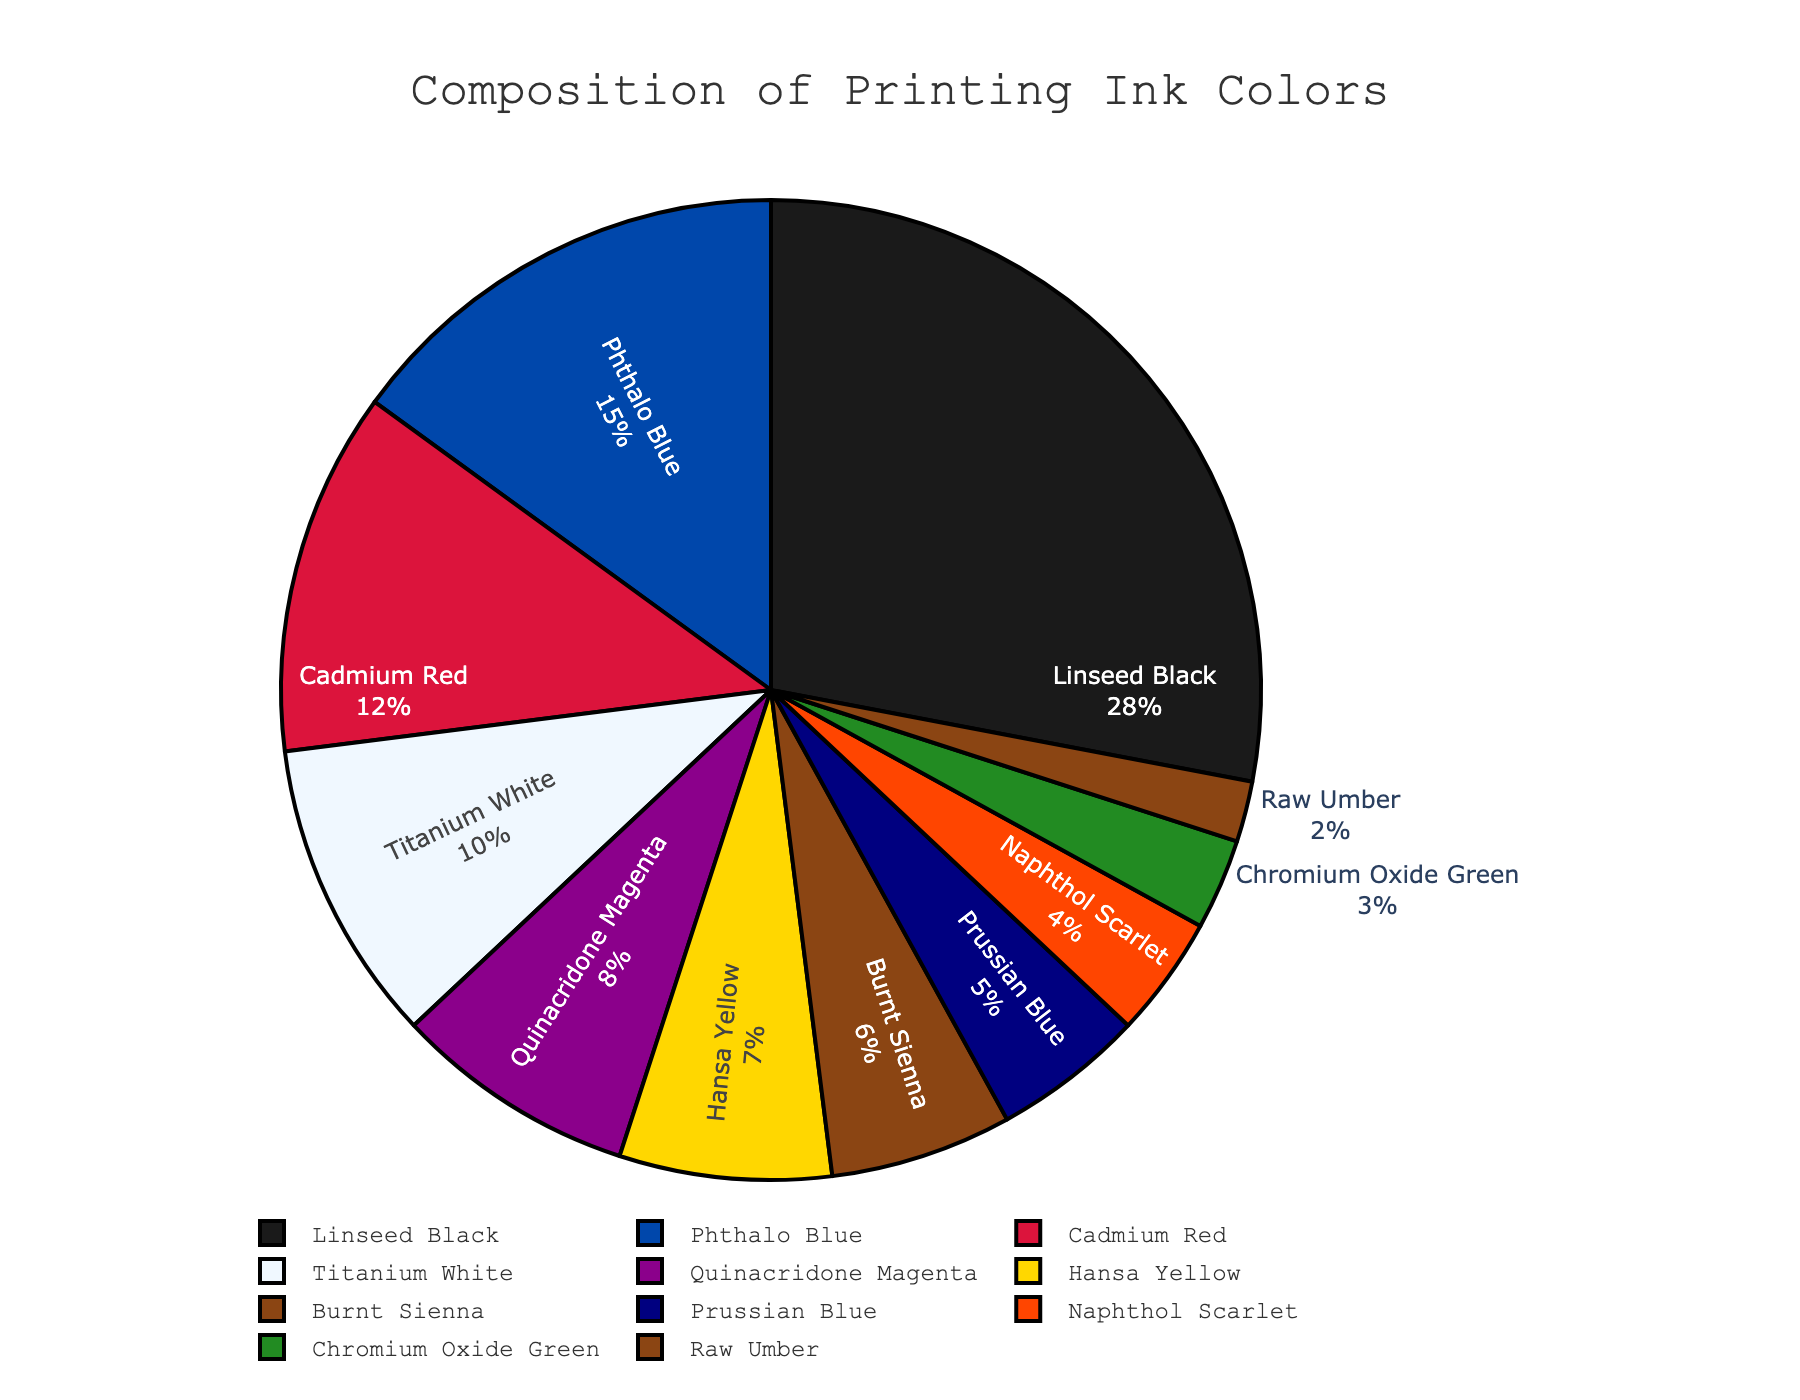What percentage of the total composition does Titanium White contribute? Locate the segment of the pie chart labeled "Titanium White" and note the percentage value shown.
Answer: 10% Compare the usage percentages of Quinacridone Magenta and Naphthol Scarlet. Which is used more and by how much? Locate the segments of the pie chart labeled "Quinacridone Magenta" and "Naphthol Scarlet." Subtract the percentage of Naphthol Scarlet from the percentage of Quinacridone Magenta: 8% - 4% = 4%.
Answer: Quinacridone Magenta, by 4% Sum the percentages of Cadmium Red, Burnt Sienna, and Prussian Blue. Locate the segments of the pie chart labeled "Cadmium Red," "Burnt Sienna," and "Prussian Blue." Add their percentages: 12% + 6% + 5% = 23%.
Answer: 23% Which color has the third highest usage percentage, and what is that percentage? Identify the segments with the highest, second highest, and third highest percentages. Linseed Black (28%), Phthalo Blue (15%), and the third highest is "Cadmium Red" (12%).
Answer: Cadmium Red, 12% Is the total percentage of Phthalo Blue and Hansa Yellow greater than that of Linseed Black? By how much? Add the percentages of Phthalo Blue and Hansa Yellow: 15% + 7% = 22%. Compare this with Linseed Black (28%). Subtract the total of Phthalo Blue and Hansa Yellow from Linseed Black: 28% - 22% = 6%.
Answer: No, by 6% How does the proportion of Raw Umber compare to Chromium Oxide Green? Locate the segments labeled "Raw Umber" and "Chromium Oxide Green." Raw Umber is 2% and Chromium Oxide Green is 3%. Raw Umber is 1% less than Chromium Oxide Green.
Answer: Raw Umber is 1% less What is the combined percentage of all colors that have single-digit usage percentages? Identify all single-digit usage segments: Quinacridone Magenta (8%), Hansa Yellow (7%), Burnt Sienna (6%), Prussian Blue (5%), Naphthol Scarlet (4%), Chromium Oxide Green (3%), Raw Umber (2%). Sum these percentages: 8% + 7% + 6% + 5% + 4% + 3% + 2% = 35%.
Answer: 35% Which color occupies the largest segment of the pie chart, and what visual characteristic makes this evident? Identify the largest segment visually and confirm with the percentage value. "Linseed Black" is the largest segment at 28%, which is easily noticeable as the largest slice.
Answer: Linseed Black, largest slice What is the difference in usage percentage between Titanium White and Phthalo Blue? Locate the segments for Titanium White (10%) and Phthalo Blue (15%). Subtract the percentage of Titanium White from Phthalo Blue: 15% - 10% = 5%.
Answer: 5% What color has the smallest segment, and what is its percentage? Identify the smallest segment visually. "Raw Umber" is the smallest segment at 2%, which is easily noticeable as the smallest slice.
Answer: Raw Umber, 2% 